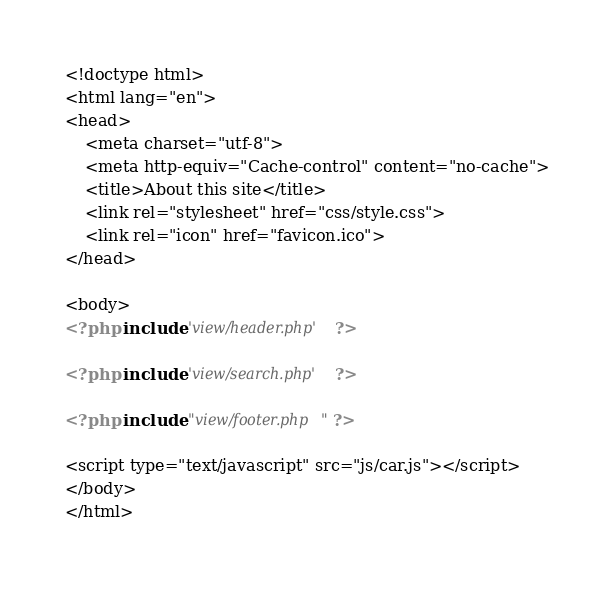Convert code to text. <code><loc_0><loc_0><loc_500><loc_500><_PHP_><!doctype html>
<html lang="en">
<head>
    <meta charset="utf-8">
    <meta http-equiv="Cache-control" content="no-cache">
    <title>About this site</title>
    <link rel="stylesheet" href="css/style.css">
    <link rel="icon" href="favicon.ico">
</head>

<body>
<?php include 'view/header.php' ?>    

<?php include 'view/search.php' ?>

<?php include "view/footer.php" ?>

<script type="text/javascript" src="js/car.js"></script>
</body>
</html>
</code> 